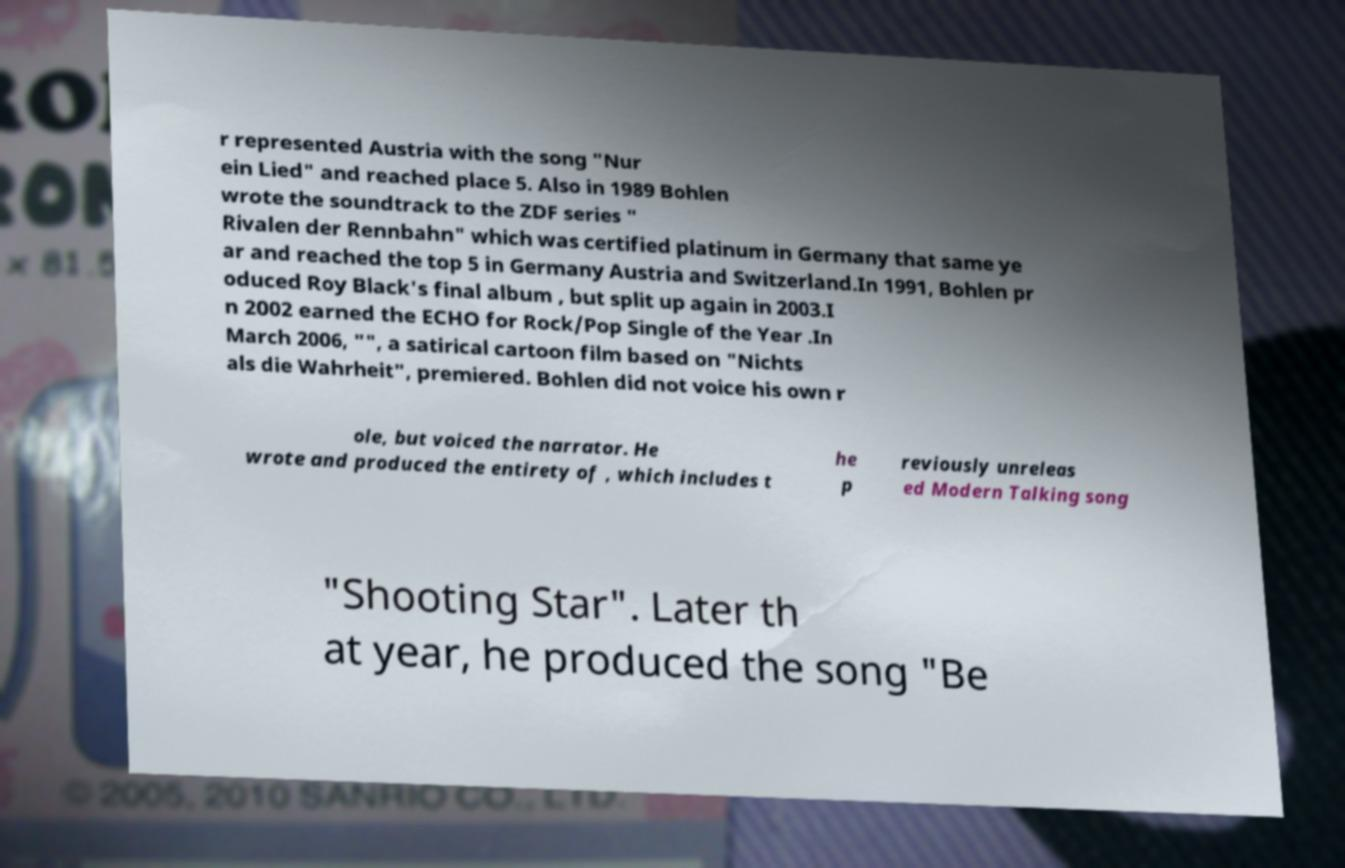Please identify and transcribe the text found in this image. r represented Austria with the song "Nur ein Lied" and reached place 5. Also in 1989 Bohlen wrote the soundtrack to the ZDF series " Rivalen der Rennbahn" which was certified platinum in Germany that same ye ar and reached the top 5 in Germany Austria and Switzerland.In 1991, Bohlen pr oduced Roy Black's final album , but split up again in 2003.I n 2002 earned the ECHO for Rock/Pop Single of the Year .In March 2006, "", a satirical cartoon film based on "Nichts als die Wahrheit", premiered. Bohlen did not voice his own r ole, but voiced the narrator. He wrote and produced the entirety of , which includes t he p reviously unreleas ed Modern Talking song "Shooting Star". Later th at year, he produced the song "Be 